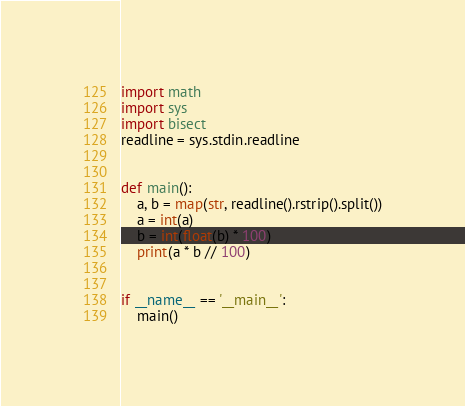Convert code to text. <code><loc_0><loc_0><loc_500><loc_500><_Python_>import math
import sys
import bisect
readline = sys.stdin.readline


def main():
    a, b = map(str, readline().rstrip().split())
    a = int(a)
    b = int(float(b) * 100)
    print(a * b // 100)


if __name__ == '__main__':
    main()
</code> 